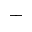Convert formula to latex. <formula><loc_0><loc_0><loc_500><loc_500>^ { + }</formula> 